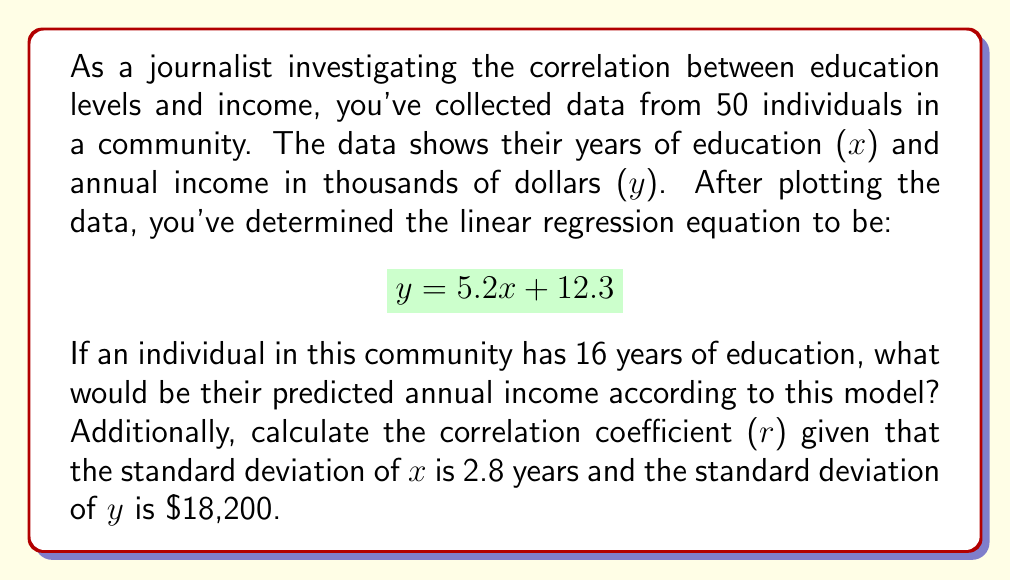Show me your answer to this math problem. To solve this problem, we'll follow these steps:

1. Use the linear regression equation to predict income for 16 years of education.
2. Calculate the correlation coefficient using the given information.

Step 1: Predicting income

We use the linear regression equation:
$$ y = 5.2x + 12.3 $$

Where x is years of education and y is annual income in thousands of dollars.

For x = 16 years:
$$ y = 5.2(16) + 12.3 $$
$$ y = 83.2 + 12.3 $$
$$ y = 95.5 $$

This means the predicted annual income is $95,500.

Step 2: Calculating the correlation coefficient

The slope of the regression line (b) is 5.2.
The standard deviation of x ($s_x$) is 2.8 years.
The standard deviation of y ($s_y$) is $18,200 or 18.2 thousand dollars.

The formula for the correlation coefficient (r) is:

$$ r = b \cdot \frac{s_x}{s_y} $$

Plugging in the values:

$$ r = 5.2 \cdot \frac{2.8}{18.2} $$
$$ r = 5.2 \cdot 0.1538 $$
$$ r = 0.8 $$

The correlation coefficient is 0.8, indicating a strong positive correlation between years of education and annual income in this community.
Answer: Predicted annual income for 16 years of education: $95,500
Correlation coefficient: 0.8 